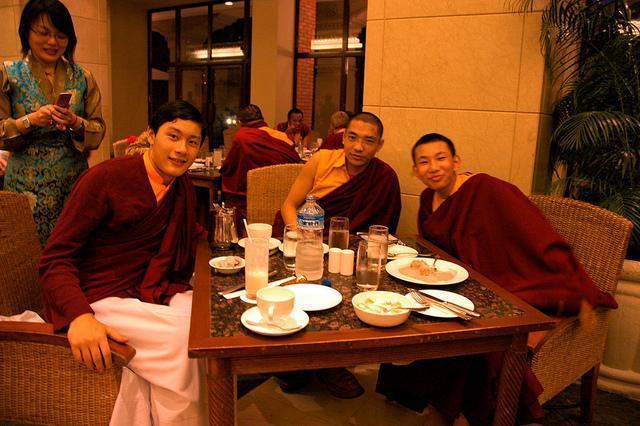How many chairs are in the picture?
Give a very brief answer. 3. How many people can you see?
Give a very brief answer. 5. How many zebras are there?
Give a very brief answer. 0. 